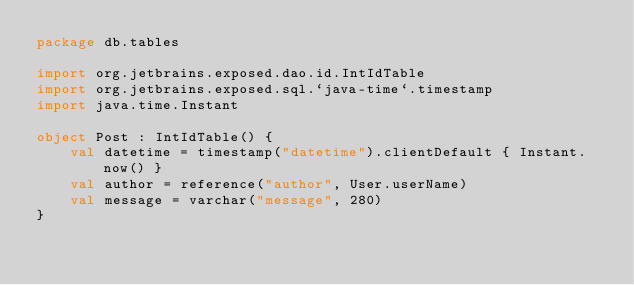Convert code to text. <code><loc_0><loc_0><loc_500><loc_500><_Kotlin_>package db.tables

import org.jetbrains.exposed.dao.id.IntIdTable
import org.jetbrains.exposed.sql.`java-time`.timestamp
import java.time.Instant

object Post : IntIdTable() {
    val datetime = timestamp("datetime").clientDefault { Instant.now() }
    val author = reference("author", User.userName)
    val message = varchar("message", 280)
}
</code> 